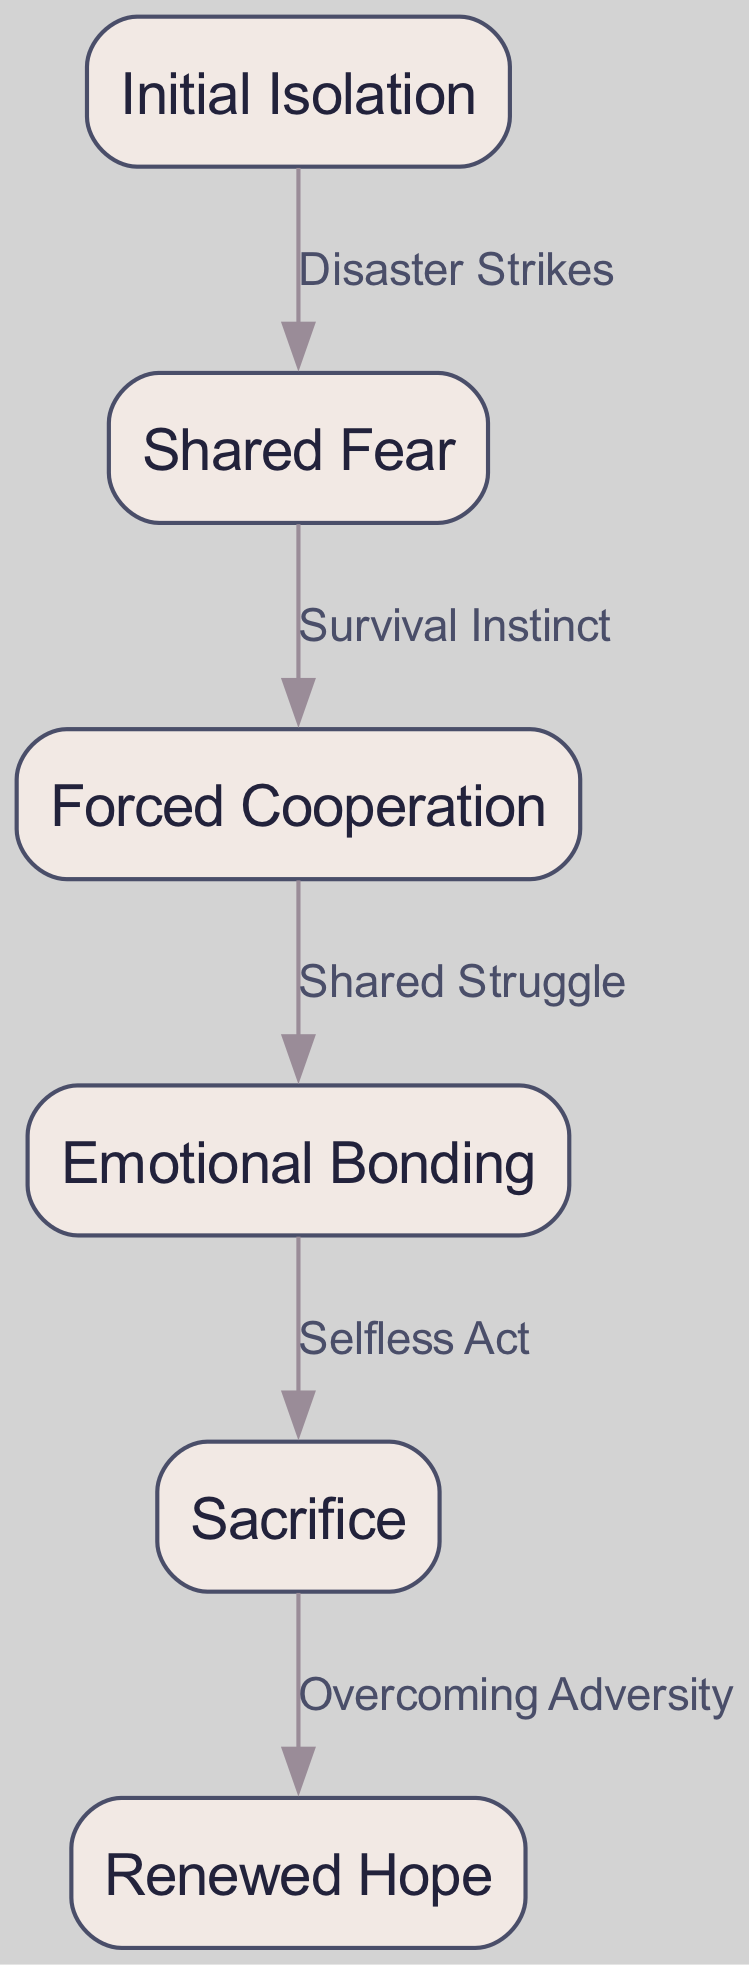What is the first stage in the emotional journey? The diagram shows "Initial Isolation" as the starting point for the emotional journey of characters in a disaster movie. It's the first node listed in the diagram.
Answer: Initial Isolation How many nodes are present in the diagram? By counting the nodes listed in the data, there are six unique emotional stages identified in the journey.
Answer: 6 What connects "Shared Fear" to "Forced Cooperation"? The relationship is defined by the edge labeled "Survival Instinct," which indicates how the characters move from feeling fear to cooperating for survival.
Answer: Survival Instinct Which stage follows "Emotional Bonding"? According to the flow of the diagram, the next stage after "Emotional Bonding" is indicated by the edge labeled "Selfless Act," leading to "Sacrifice."
Answer: Sacrifice What is the relationship between "Initial Isolation" and "Shared Fear"? The edge labeled "Disaster Strikes" represents the connection from "Initial Isolation" to "Shared Fear," showing that the event of a disaster creates a shift in emotions.
Answer: Disaster Strikes What is the last stage in the emotional journey? The final node in the sequence is "Renewed Hope," which marks the culmination of the characters' emotional development following their trials.
Answer: Renewed Hope What are the stages that involve selflessness? The stages depicting selflessness are "Emotional Bonding," where relationships grow, leading into "Sacrifice," representing a selfless act for others.
Answer: Emotional Bonding, Sacrifice Which edge signifies a transition from struggle to cooperation? The edge labeled "Shared Struggle" indicates the transition from the stage of "Forced Cooperation" to "Emotional Bonding," emphasizing the importance of collective challenges.
Answer: Shared Struggle 